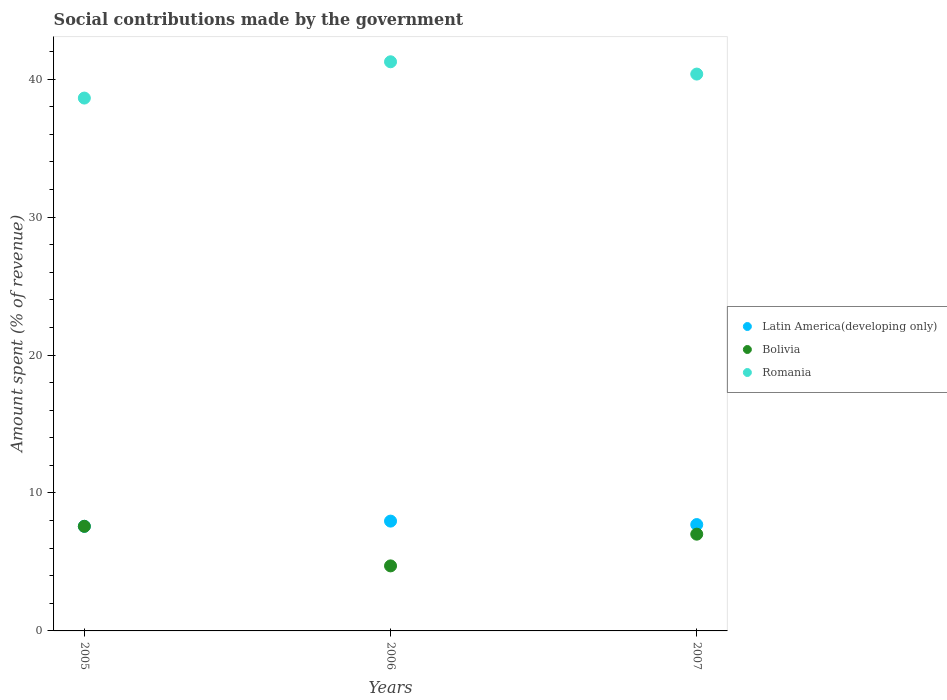How many different coloured dotlines are there?
Offer a terse response. 3. What is the amount spent (in %) on social contributions in Romania in 2007?
Make the answer very short. 40.37. Across all years, what is the maximum amount spent (in %) on social contributions in Bolivia?
Offer a terse response. 7.58. Across all years, what is the minimum amount spent (in %) on social contributions in Latin America(developing only)?
Make the answer very short. 7.58. What is the total amount spent (in %) on social contributions in Romania in the graph?
Your answer should be compact. 120.27. What is the difference between the amount spent (in %) on social contributions in Romania in 2005 and that in 2006?
Your response must be concise. -2.63. What is the difference between the amount spent (in %) on social contributions in Latin America(developing only) in 2006 and the amount spent (in %) on social contributions in Romania in 2005?
Keep it short and to the point. -30.67. What is the average amount spent (in %) on social contributions in Latin America(developing only) per year?
Your answer should be compact. 7.75. In the year 2005, what is the difference between the amount spent (in %) on social contributions in Bolivia and amount spent (in %) on social contributions in Romania?
Offer a very short reply. -31.05. What is the ratio of the amount spent (in %) on social contributions in Latin America(developing only) in 2005 to that in 2006?
Your answer should be very brief. 0.95. Is the difference between the amount spent (in %) on social contributions in Bolivia in 2006 and 2007 greater than the difference between the amount spent (in %) on social contributions in Romania in 2006 and 2007?
Keep it short and to the point. No. What is the difference between the highest and the second highest amount spent (in %) on social contributions in Latin America(developing only)?
Give a very brief answer. 0.25. What is the difference between the highest and the lowest amount spent (in %) on social contributions in Latin America(developing only)?
Your answer should be compact. 0.38. In how many years, is the amount spent (in %) on social contributions in Latin America(developing only) greater than the average amount spent (in %) on social contributions in Latin America(developing only) taken over all years?
Provide a short and direct response. 1. Does the amount spent (in %) on social contributions in Bolivia monotonically increase over the years?
Keep it short and to the point. No. Is the amount spent (in %) on social contributions in Latin America(developing only) strictly greater than the amount spent (in %) on social contributions in Romania over the years?
Your response must be concise. No. What is the difference between two consecutive major ticks on the Y-axis?
Keep it short and to the point. 10. Are the values on the major ticks of Y-axis written in scientific E-notation?
Provide a short and direct response. No. Where does the legend appear in the graph?
Offer a terse response. Center right. What is the title of the graph?
Your answer should be compact. Social contributions made by the government. What is the label or title of the Y-axis?
Give a very brief answer. Amount spent (% of revenue). What is the Amount spent (% of revenue) in Latin America(developing only) in 2005?
Your answer should be very brief. 7.58. What is the Amount spent (% of revenue) in Bolivia in 2005?
Make the answer very short. 7.58. What is the Amount spent (% of revenue) in Romania in 2005?
Provide a short and direct response. 38.63. What is the Amount spent (% of revenue) of Latin America(developing only) in 2006?
Your answer should be very brief. 7.96. What is the Amount spent (% of revenue) of Bolivia in 2006?
Your response must be concise. 4.72. What is the Amount spent (% of revenue) of Romania in 2006?
Give a very brief answer. 41.27. What is the Amount spent (% of revenue) in Latin America(developing only) in 2007?
Your response must be concise. 7.71. What is the Amount spent (% of revenue) in Bolivia in 2007?
Your answer should be compact. 7.02. What is the Amount spent (% of revenue) in Romania in 2007?
Ensure brevity in your answer.  40.37. Across all years, what is the maximum Amount spent (% of revenue) of Latin America(developing only)?
Ensure brevity in your answer.  7.96. Across all years, what is the maximum Amount spent (% of revenue) of Bolivia?
Offer a terse response. 7.58. Across all years, what is the maximum Amount spent (% of revenue) of Romania?
Your answer should be very brief. 41.27. Across all years, what is the minimum Amount spent (% of revenue) in Latin America(developing only)?
Provide a succinct answer. 7.58. Across all years, what is the minimum Amount spent (% of revenue) of Bolivia?
Your response must be concise. 4.72. Across all years, what is the minimum Amount spent (% of revenue) of Romania?
Your answer should be very brief. 38.63. What is the total Amount spent (% of revenue) in Latin America(developing only) in the graph?
Offer a very short reply. 23.26. What is the total Amount spent (% of revenue) in Bolivia in the graph?
Ensure brevity in your answer.  19.32. What is the total Amount spent (% of revenue) in Romania in the graph?
Keep it short and to the point. 120.27. What is the difference between the Amount spent (% of revenue) in Latin America(developing only) in 2005 and that in 2006?
Give a very brief answer. -0.38. What is the difference between the Amount spent (% of revenue) of Bolivia in 2005 and that in 2006?
Your answer should be compact. 2.87. What is the difference between the Amount spent (% of revenue) of Romania in 2005 and that in 2006?
Give a very brief answer. -2.63. What is the difference between the Amount spent (% of revenue) in Latin America(developing only) in 2005 and that in 2007?
Your answer should be compact. -0.13. What is the difference between the Amount spent (% of revenue) of Bolivia in 2005 and that in 2007?
Make the answer very short. 0.57. What is the difference between the Amount spent (% of revenue) of Romania in 2005 and that in 2007?
Give a very brief answer. -1.74. What is the difference between the Amount spent (% of revenue) in Latin America(developing only) in 2006 and that in 2007?
Keep it short and to the point. 0.25. What is the difference between the Amount spent (% of revenue) of Bolivia in 2006 and that in 2007?
Give a very brief answer. -2.3. What is the difference between the Amount spent (% of revenue) of Romania in 2006 and that in 2007?
Offer a very short reply. 0.89. What is the difference between the Amount spent (% of revenue) in Latin America(developing only) in 2005 and the Amount spent (% of revenue) in Bolivia in 2006?
Your response must be concise. 2.87. What is the difference between the Amount spent (% of revenue) of Latin America(developing only) in 2005 and the Amount spent (% of revenue) of Romania in 2006?
Your answer should be compact. -33.68. What is the difference between the Amount spent (% of revenue) in Bolivia in 2005 and the Amount spent (% of revenue) in Romania in 2006?
Offer a terse response. -33.68. What is the difference between the Amount spent (% of revenue) in Latin America(developing only) in 2005 and the Amount spent (% of revenue) in Bolivia in 2007?
Keep it short and to the point. 0.57. What is the difference between the Amount spent (% of revenue) of Latin America(developing only) in 2005 and the Amount spent (% of revenue) of Romania in 2007?
Make the answer very short. -32.79. What is the difference between the Amount spent (% of revenue) in Bolivia in 2005 and the Amount spent (% of revenue) in Romania in 2007?
Offer a very short reply. -32.79. What is the difference between the Amount spent (% of revenue) in Latin America(developing only) in 2006 and the Amount spent (% of revenue) in Bolivia in 2007?
Keep it short and to the point. 0.95. What is the difference between the Amount spent (% of revenue) in Latin America(developing only) in 2006 and the Amount spent (% of revenue) in Romania in 2007?
Provide a succinct answer. -32.41. What is the difference between the Amount spent (% of revenue) of Bolivia in 2006 and the Amount spent (% of revenue) of Romania in 2007?
Offer a terse response. -35.66. What is the average Amount spent (% of revenue) of Latin America(developing only) per year?
Provide a succinct answer. 7.75. What is the average Amount spent (% of revenue) of Bolivia per year?
Give a very brief answer. 6.44. What is the average Amount spent (% of revenue) of Romania per year?
Provide a succinct answer. 40.09. In the year 2005, what is the difference between the Amount spent (% of revenue) in Latin America(developing only) and Amount spent (% of revenue) in Bolivia?
Your answer should be very brief. 0. In the year 2005, what is the difference between the Amount spent (% of revenue) in Latin America(developing only) and Amount spent (% of revenue) in Romania?
Provide a succinct answer. -31.05. In the year 2005, what is the difference between the Amount spent (% of revenue) of Bolivia and Amount spent (% of revenue) of Romania?
Provide a short and direct response. -31.05. In the year 2006, what is the difference between the Amount spent (% of revenue) of Latin America(developing only) and Amount spent (% of revenue) of Bolivia?
Offer a terse response. 3.25. In the year 2006, what is the difference between the Amount spent (% of revenue) of Latin America(developing only) and Amount spent (% of revenue) of Romania?
Ensure brevity in your answer.  -33.3. In the year 2006, what is the difference between the Amount spent (% of revenue) in Bolivia and Amount spent (% of revenue) in Romania?
Provide a succinct answer. -36.55. In the year 2007, what is the difference between the Amount spent (% of revenue) in Latin America(developing only) and Amount spent (% of revenue) in Bolivia?
Offer a terse response. 0.7. In the year 2007, what is the difference between the Amount spent (% of revenue) of Latin America(developing only) and Amount spent (% of revenue) of Romania?
Offer a terse response. -32.66. In the year 2007, what is the difference between the Amount spent (% of revenue) in Bolivia and Amount spent (% of revenue) in Romania?
Ensure brevity in your answer.  -33.36. What is the ratio of the Amount spent (% of revenue) of Latin America(developing only) in 2005 to that in 2006?
Offer a terse response. 0.95. What is the ratio of the Amount spent (% of revenue) in Bolivia in 2005 to that in 2006?
Provide a short and direct response. 1.61. What is the ratio of the Amount spent (% of revenue) of Romania in 2005 to that in 2006?
Provide a succinct answer. 0.94. What is the ratio of the Amount spent (% of revenue) of Latin America(developing only) in 2005 to that in 2007?
Provide a short and direct response. 0.98. What is the ratio of the Amount spent (% of revenue) in Bolivia in 2005 to that in 2007?
Your answer should be compact. 1.08. What is the ratio of the Amount spent (% of revenue) of Romania in 2005 to that in 2007?
Give a very brief answer. 0.96. What is the ratio of the Amount spent (% of revenue) of Latin America(developing only) in 2006 to that in 2007?
Provide a short and direct response. 1.03. What is the ratio of the Amount spent (% of revenue) of Bolivia in 2006 to that in 2007?
Offer a very short reply. 0.67. What is the ratio of the Amount spent (% of revenue) of Romania in 2006 to that in 2007?
Your answer should be compact. 1.02. What is the difference between the highest and the second highest Amount spent (% of revenue) in Latin America(developing only)?
Provide a short and direct response. 0.25. What is the difference between the highest and the second highest Amount spent (% of revenue) in Bolivia?
Offer a very short reply. 0.57. What is the difference between the highest and the second highest Amount spent (% of revenue) of Romania?
Your answer should be compact. 0.89. What is the difference between the highest and the lowest Amount spent (% of revenue) of Latin America(developing only)?
Your answer should be compact. 0.38. What is the difference between the highest and the lowest Amount spent (% of revenue) in Bolivia?
Ensure brevity in your answer.  2.87. What is the difference between the highest and the lowest Amount spent (% of revenue) of Romania?
Give a very brief answer. 2.63. 